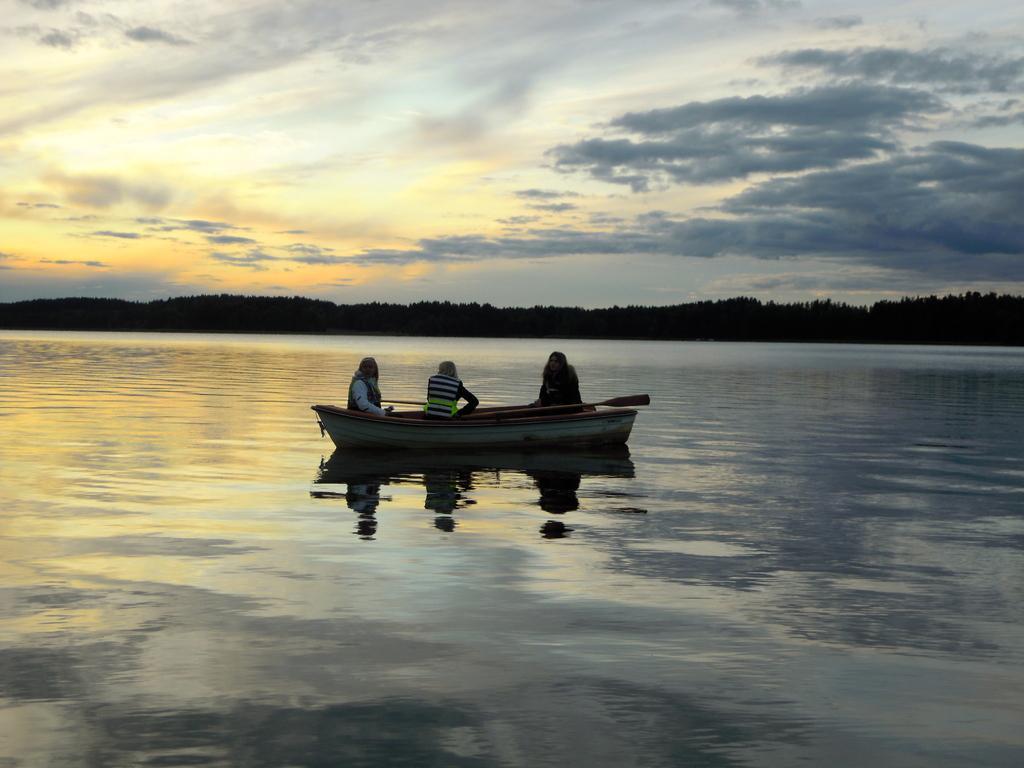Could you give a brief overview of what you see in this image? In this image there is a boat on the water. There are three people on the boat. In the background there are trees. At the top there is the sky. 